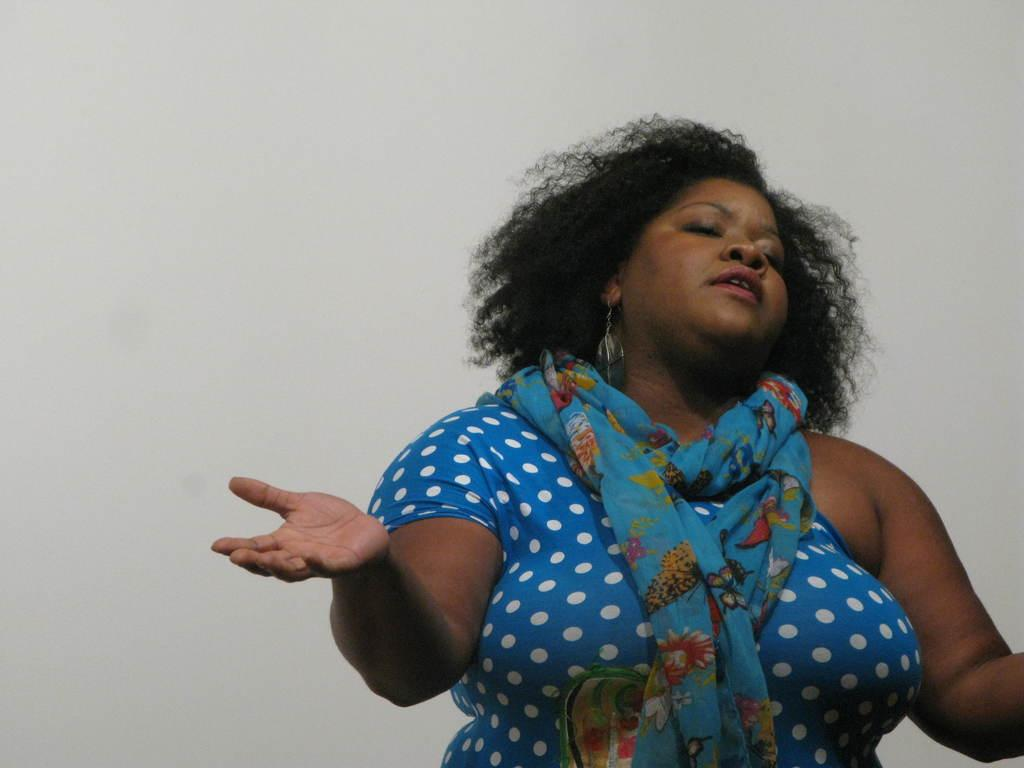Who or what is present in the image? There is a person in the image. Can you describe the person's attire? The person is wearing clothes and a scarf. What type of tank is visible in the image? There is no tank present in the image; it features a person wearing clothes and a scarf. What hobbies does the person in the image have? The image does not provide information about the person's hobbies. 